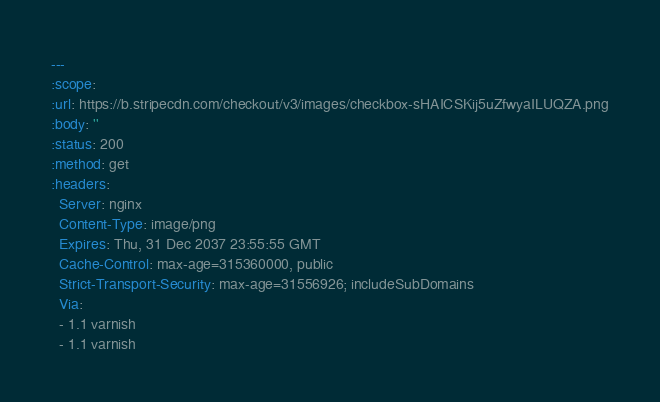<code> <loc_0><loc_0><loc_500><loc_500><_YAML_>---
:scope: 
:url: https://b.stripecdn.com/checkout/v3/images/checkbox-sHAICSKij5uZfwyaILUQZA.png
:body: ''
:status: 200
:method: get
:headers:
  Server: nginx
  Content-Type: image/png
  Expires: Thu, 31 Dec 2037 23:55:55 GMT
  Cache-Control: max-age=315360000, public
  Strict-Transport-Security: max-age=31556926; includeSubDomains
  Via:
  - 1.1 varnish
  - 1.1 varnish</code> 